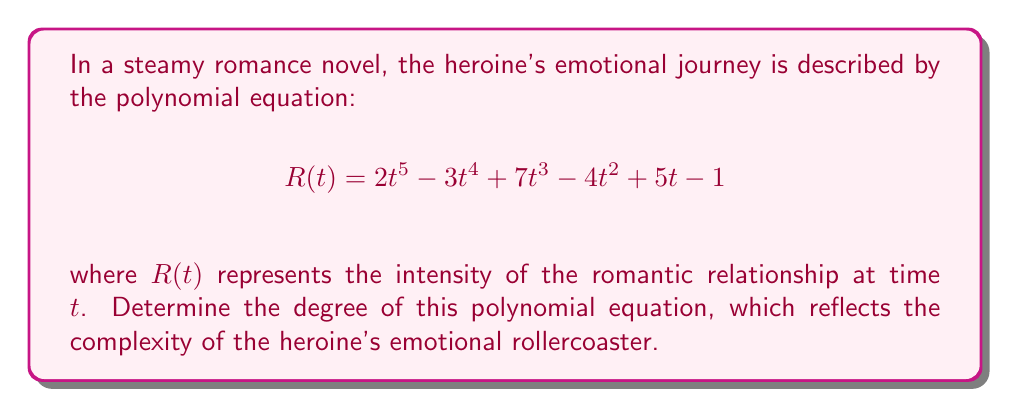Can you answer this question? To determine the degree of a polynomial equation, we need to identify the highest power of the variable in the equation. Let's break down the given polynomial:

1) $2t^5$: The highest power of $t$ here is 5
2) $-3t^4$: The highest power of $t$ here is 4
3) $7t^3$: The highest power of $t$ here is 3
4) $-4t^2$: The highest power of $t$ here is 2
5) $5t$: The highest power of $t$ here is 1
6) $-1$: This is a constant term, so the power of $t$ is 0

Among all these terms, the highest power of $t$ is 5, which appears in the first term $2t^5$.

Therefore, the degree of this polynomial equation is 5.

In the context of the romance novel, this means that the heroine's emotional journey is quite complex, with potentially multiple ups and downs, mirroring the intricate plot twists often found in romance stories.
Answer: 5 